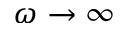Convert formula to latex. <formula><loc_0><loc_0><loc_500><loc_500>\omega \to \infty</formula> 